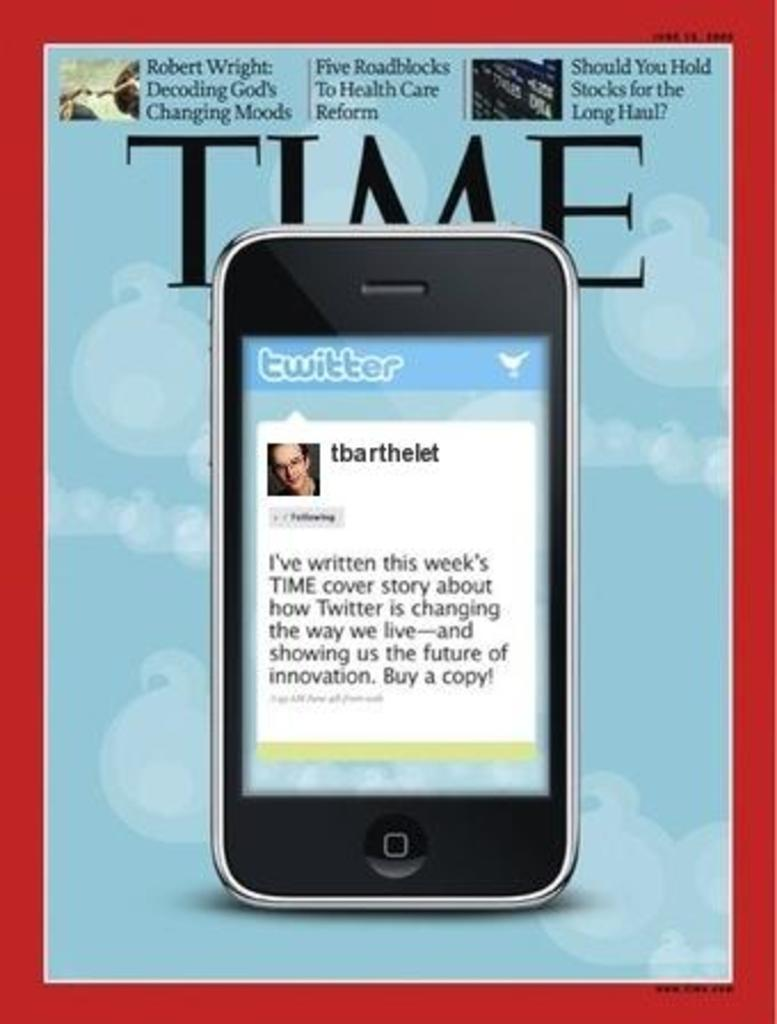<image>
Describe the image concisely. Time magazine cover with a phone with twitter on its screen on it. 